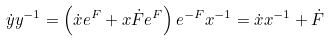<formula> <loc_0><loc_0><loc_500><loc_500>\dot { y } y ^ { - 1 } = \left ( \dot { x } e ^ { F } + x \dot { F } e ^ { F } \right ) e ^ { - F } x ^ { - 1 } = \dot { x } x ^ { - 1 } + \dot { F }</formula> 